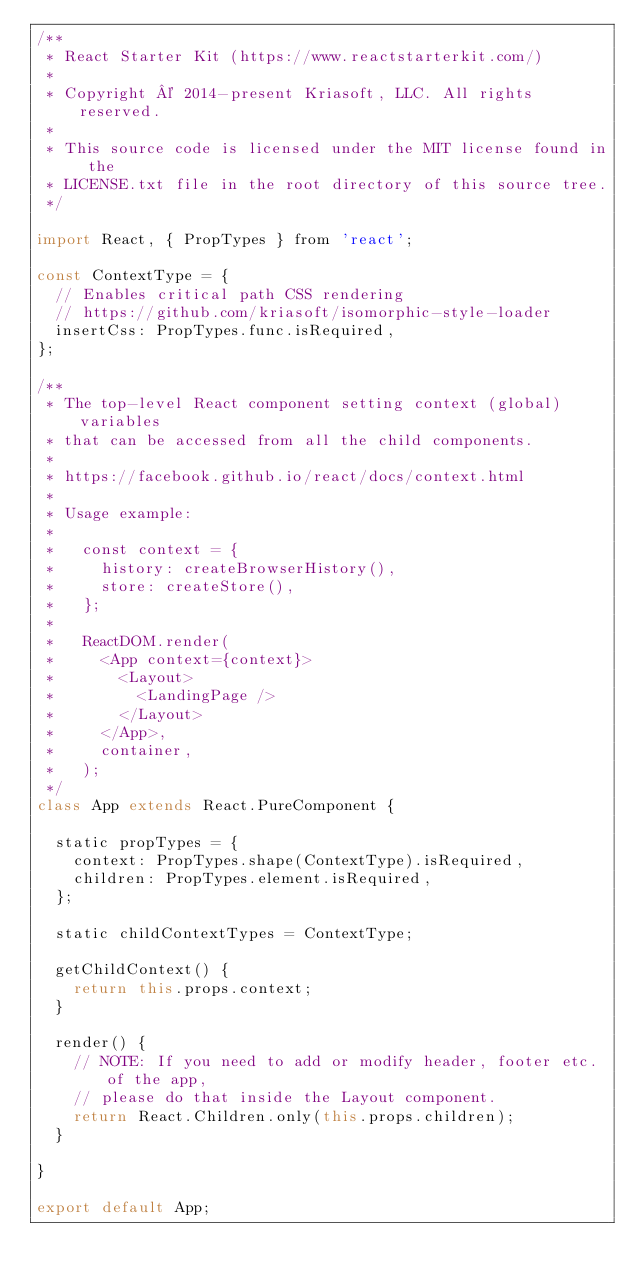Convert code to text. <code><loc_0><loc_0><loc_500><loc_500><_JavaScript_>/**
 * React Starter Kit (https://www.reactstarterkit.com/)
 *
 * Copyright © 2014-present Kriasoft, LLC. All rights reserved.
 *
 * This source code is licensed under the MIT license found in the
 * LICENSE.txt file in the root directory of this source tree.
 */

import React, { PropTypes } from 'react';

const ContextType = {
  // Enables critical path CSS rendering
  // https://github.com/kriasoft/isomorphic-style-loader
  insertCss: PropTypes.func.isRequired,
};

/**
 * The top-level React component setting context (global) variables
 * that can be accessed from all the child components.
 *
 * https://facebook.github.io/react/docs/context.html
 *
 * Usage example:
 *
 *   const context = {
 *     history: createBrowserHistory(),
 *     store: createStore(),
 *   };
 *
 *   ReactDOM.render(
 *     <App context={context}>
 *       <Layout>
 *         <LandingPage />
 *       </Layout>
 *     </App>,
 *     container,
 *   );
 */
class App extends React.PureComponent {

  static propTypes = {
    context: PropTypes.shape(ContextType).isRequired,
    children: PropTypes.element.isRequired,
  };

  static childContextTypes = ContextType;

  getChildContext() {
    return this.props.context;
  }

  render() {
    // NOTE: If you need to add or modify header, footer etc. of the app,
    // please do that inside the Layout component.
    return React.Children.only(this.props.children);
  }

}

export default App;
</code> 